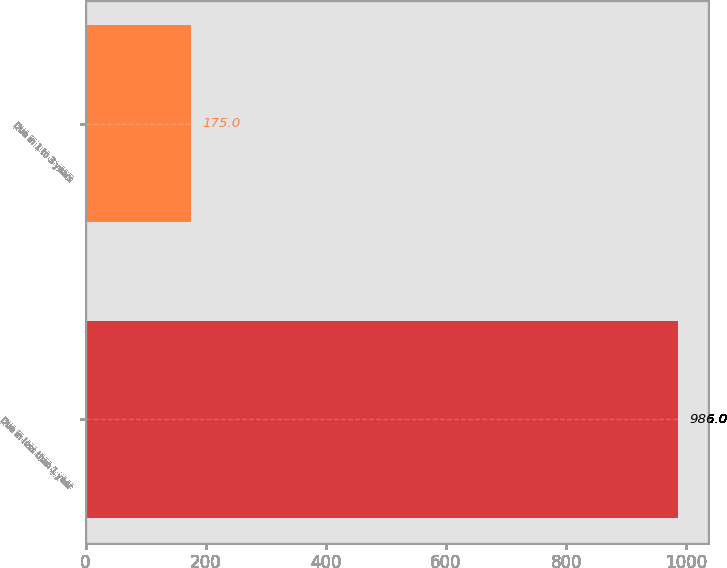Convert chart. <chart><loc_0><loc_0><loc_500><loc_500><bar_chart><fcel>Due in less than 1 year<fcel>Due in 1 to 3 years<nl><fcel>986<fcel>175<nl></chart> 